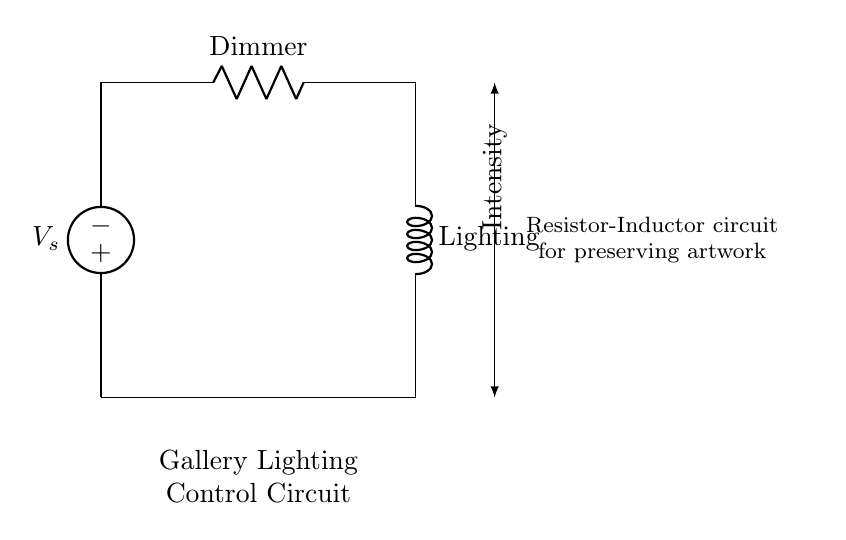What are the components in the circuit? The circuit includes a voltage source, a resistor labeled as "Dimmer," and an inductor labeled as "Lighting." Identifying the elements from the diagram helps to delineate the function each serves.
Answer: Voltage source, Dimmer, Lighting What function does the resistor serve in this circuit? The resistor, labeled as "Dimmer," is used to control the intensity of the gallery lighting by varying the resistance in the circuit. This adjustment impacts the current flow, which directly correlates with the brightness of the lights.
Answer: Control intensity What is the role of the inductor in this circuit? The inductor labeled as "Lighting" functions to smooth out fluctuations in the current and provides lagging current which is beneficial for lighting applications. Inductors store energy in a magnetic field when current flows through them.
Answer: Smooth current How does increasing resistance affect the circuit's intensity? Increasing the resistance from the dimmer reduces the current flowing through the circuit, which consequently lowers the intensity of light emitted from the lighting inductor. The relationship of resistance to current flow is described by Ohm’s Law.
Answer: Decreases intensity What type of circuit is this? This is an R-L circuit, where R stands for the resistor and L denotes the inductor, which are typically used in various applications for controlling current and voltage levels.
Answer: R-L circuit What is the purpose of this circuit in relation to artwork? The circuit is designed to control the lighting intensity in a gallery setting, which is critical to help preserve artwork by minimizing light damage over time. The careful management of light exposure is key to maintaining the integrity of the art.
Answer: Artwork preservation What does the arrow on the side indicate? The arrow indicates a dependent measure related to intensity, showing how the adjustments made in this circuit will affect the variable of light output. It illustrates the interaction between the resistance and resultant current levels in the system.
Answer: Intensity measurement 